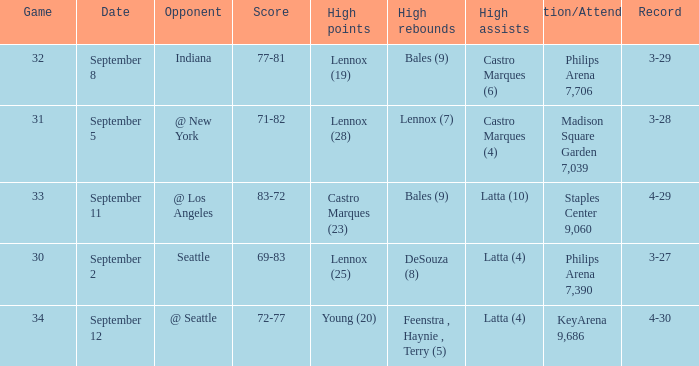When did indiana play? September 8. 